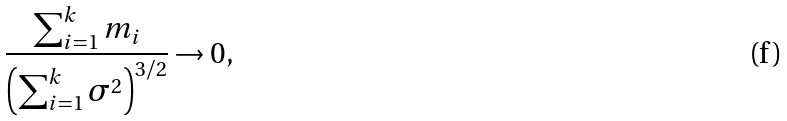<formula> <loc_0><loc_0><loc_500><loc_500>\frac { \sum _ { i = 1 } ^ { k } m _ { i } } { \left ( \sum _ { i = 1 } ^ { k } \sigma ^ { 2 } \right ) ^ { 3 / 2 } } \rightarrow 0 ,</formula> 